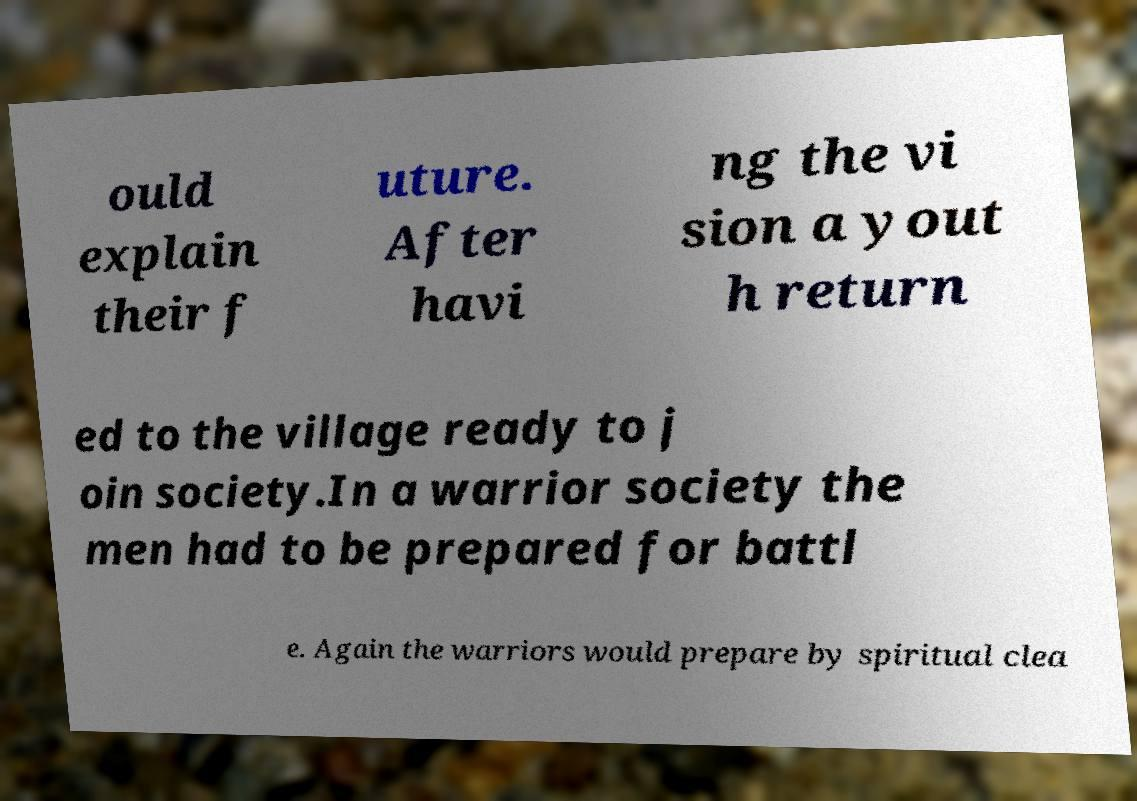Could you extract and type out the text from this image? ould explain their f uture. After havi ng the vi sion a yout h return ed to the village ready to j oin society.In a warrior society the men had to be prepared for battl e. Again the warriors would prepare by spiritual clea 